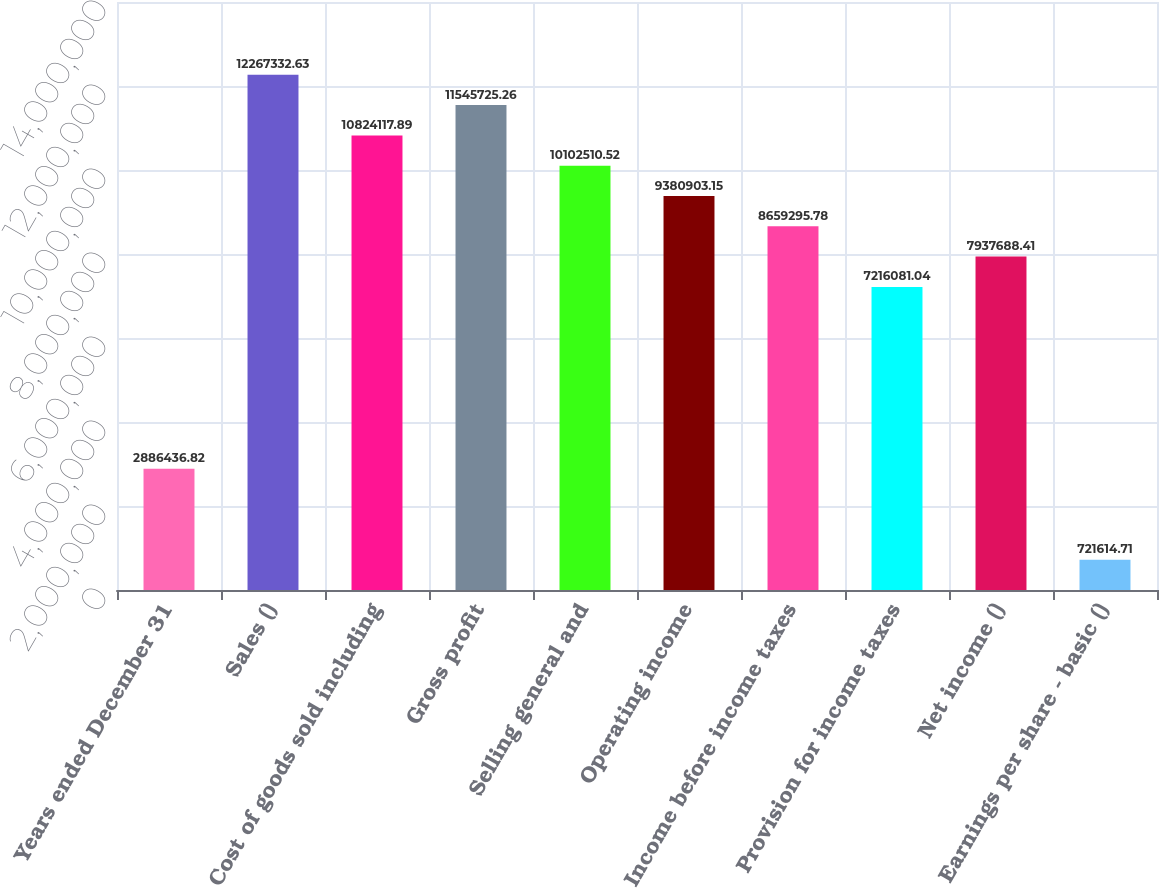Convert chart. <chart><loc_0><loc_0><loc_500><loc_500><bar_chart><fcel>Years ended December 31<fcel>Sales ()<fcel>Cost of goods sold including<fcel>Gross profit<fcel>Selling general and<fcel>Operating income<fcel>Income before income taxes<fcel>Provision for income taxes<fcel>Net income ()<fcel>Earnings per share - basic ()<nl><fcel>2.88644e+06<fcel>1.22673e+07<fcel>1.08241e+07<fcel>1.15457e+07<fcel>1.01025e+07<fcel>9.3809e+06<fcel>8.6593e+06<fcel>7.21608e+06<fcel>7.93769e+06<fcel>721615<nl></chart> 